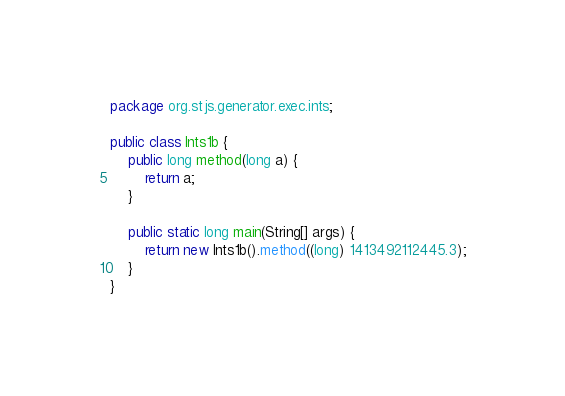Convert code to text. <code><loc_0><loc_0><loc_500><loc_500><_Java_>package org.stjs.generator.exec.ints;

public class Ints1b {
	public long method(long a) {
		return a;
	}

	public static long main(String[] args) {
		return new Ints1b().method((long) 1413492112445.3);
	}
}
</code> 